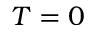<formula> <loc_0><loc_0><loc_500><loc_500>T = 0</formula> 